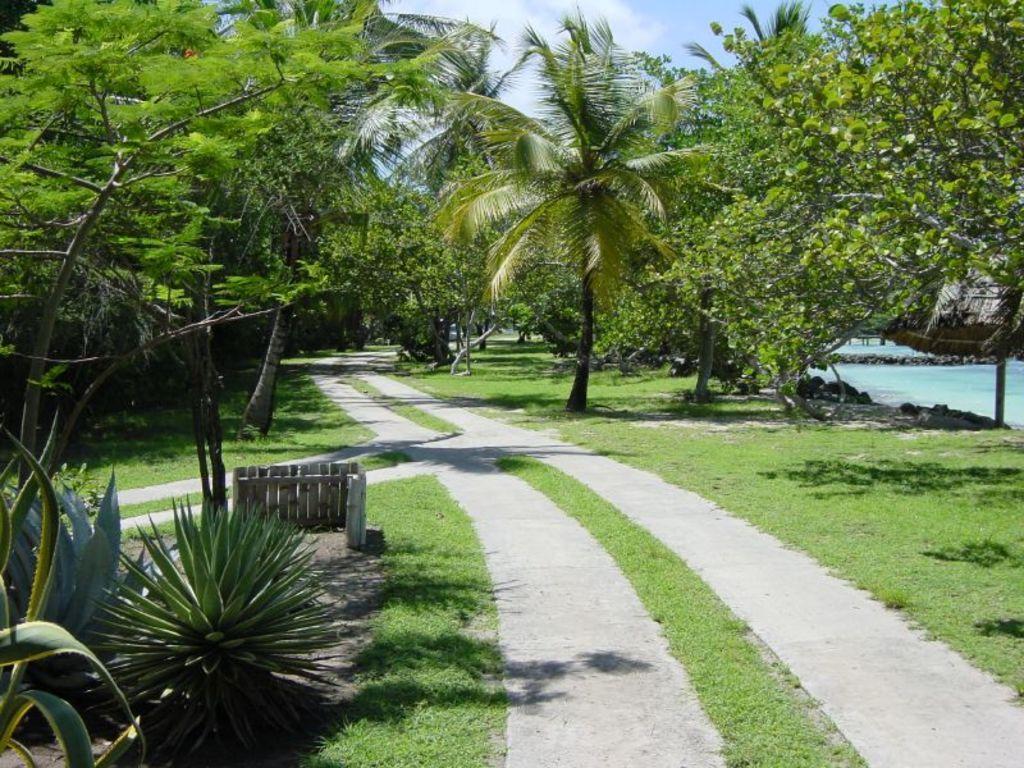Describe this image in one or two sentences. In this image we can see some trees and plants and there is a path in between the trees. On the right side of the image we can see the water and at the top we can see the sky. 